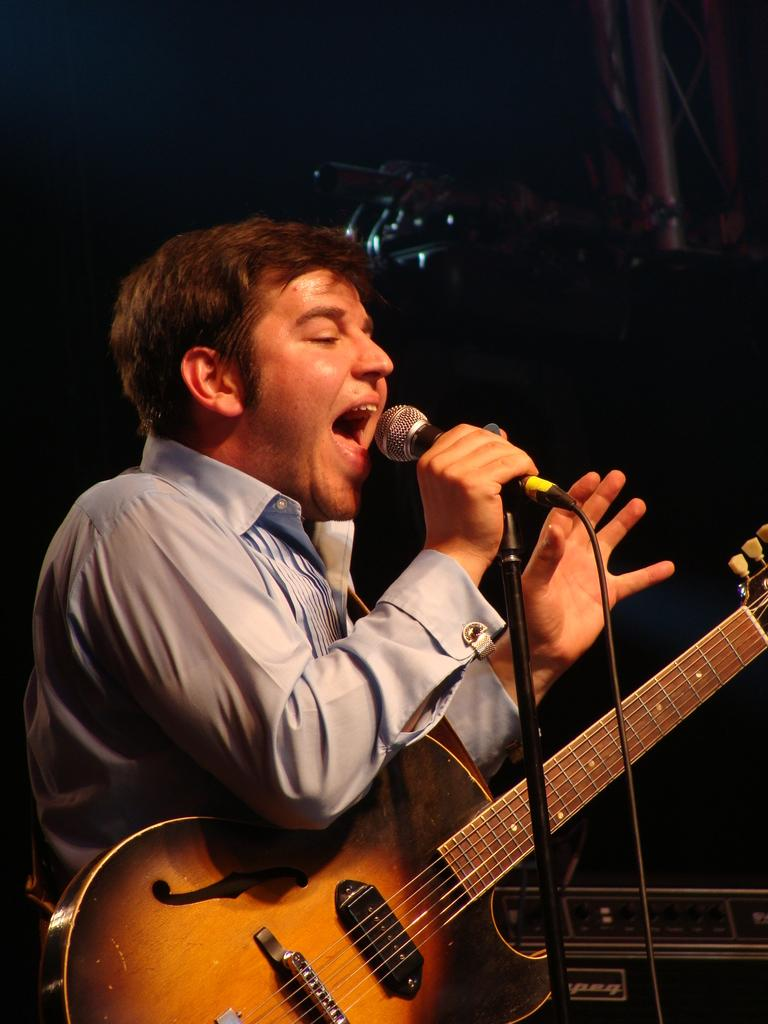What is the man in the image doing? The man is singing in the image. What is the man holding while singing? The man is holding a microphone in the image. What musical instrument does the man have? The man has a guitar in the image. Where is the vase located in the image? There is no vase present in the image. What type of rail can be seen in the image? There is no rail present in the image. 